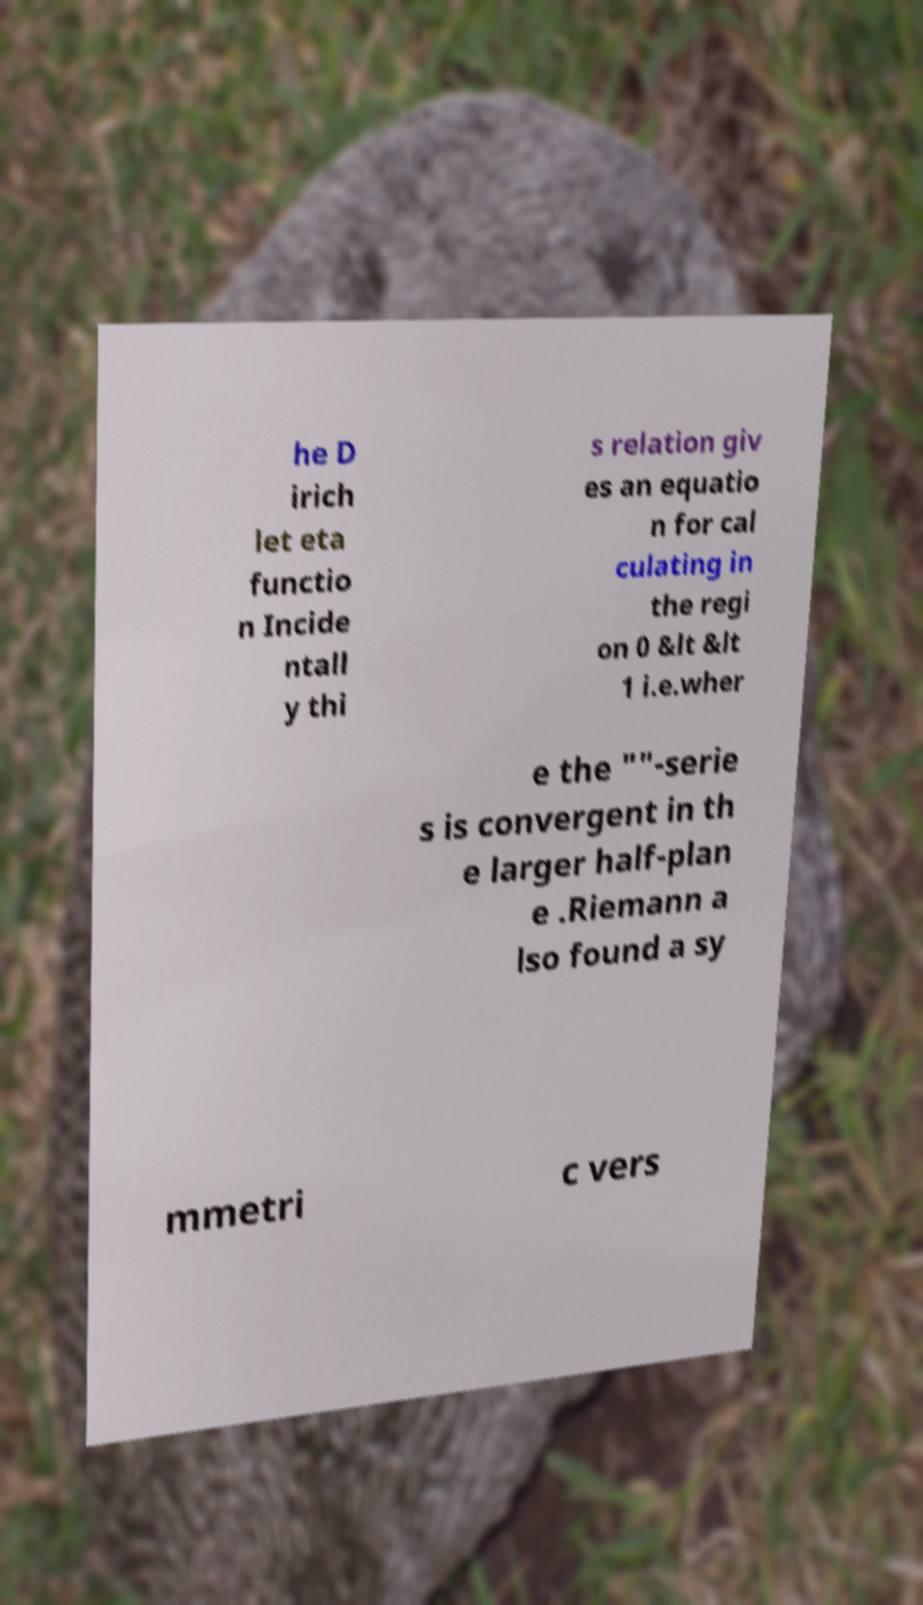Can you read and provide the text displayed in the image?This photo seems to have some interesting text. Can you extract and type it out for me? he D irich let eta functio n Incide ntall y thi s relation giv es an equatio n for cal culating in the regi on 0 &lt &lt 1 i.e.wher e the ""-serie s is convergent in th e larger half-plan e .Riemann a lso found a sy mmetri c vers 